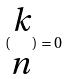<formula> <loc_0><loc_0><loc_500><loc_500>( \begin{matrix} k \\ n \end{matrix} ) = 0</formula> 